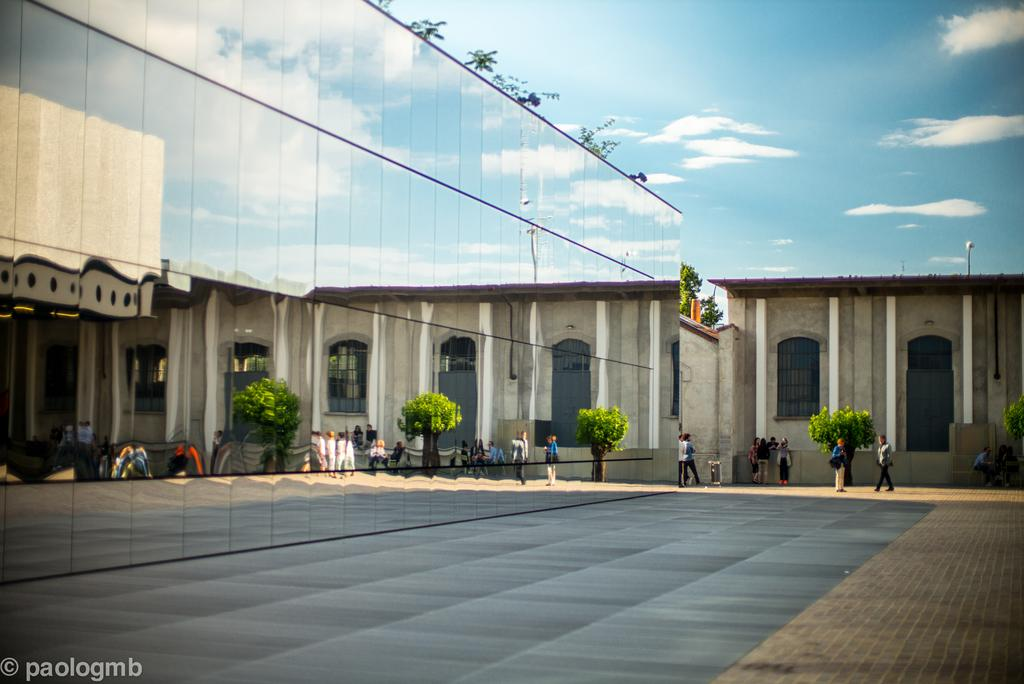What type of structure is present in the image? The image contains a building. What is unique about the building's walls? The building has glass walls. Are there any openings in the building's walls? Yes, the building has windows. What can be seen in front of the building? There are people and trees in front of the building. What type of vegetation is present in front of the building? There are plants in front of the building. What type of ticket can be seen in the image? There is no ticket present in the image. What is the weather like in the image, based on the presence of clouds? The provided facts do not mention any clouds in the image, so it is not possible to determine the weather based on this information. 